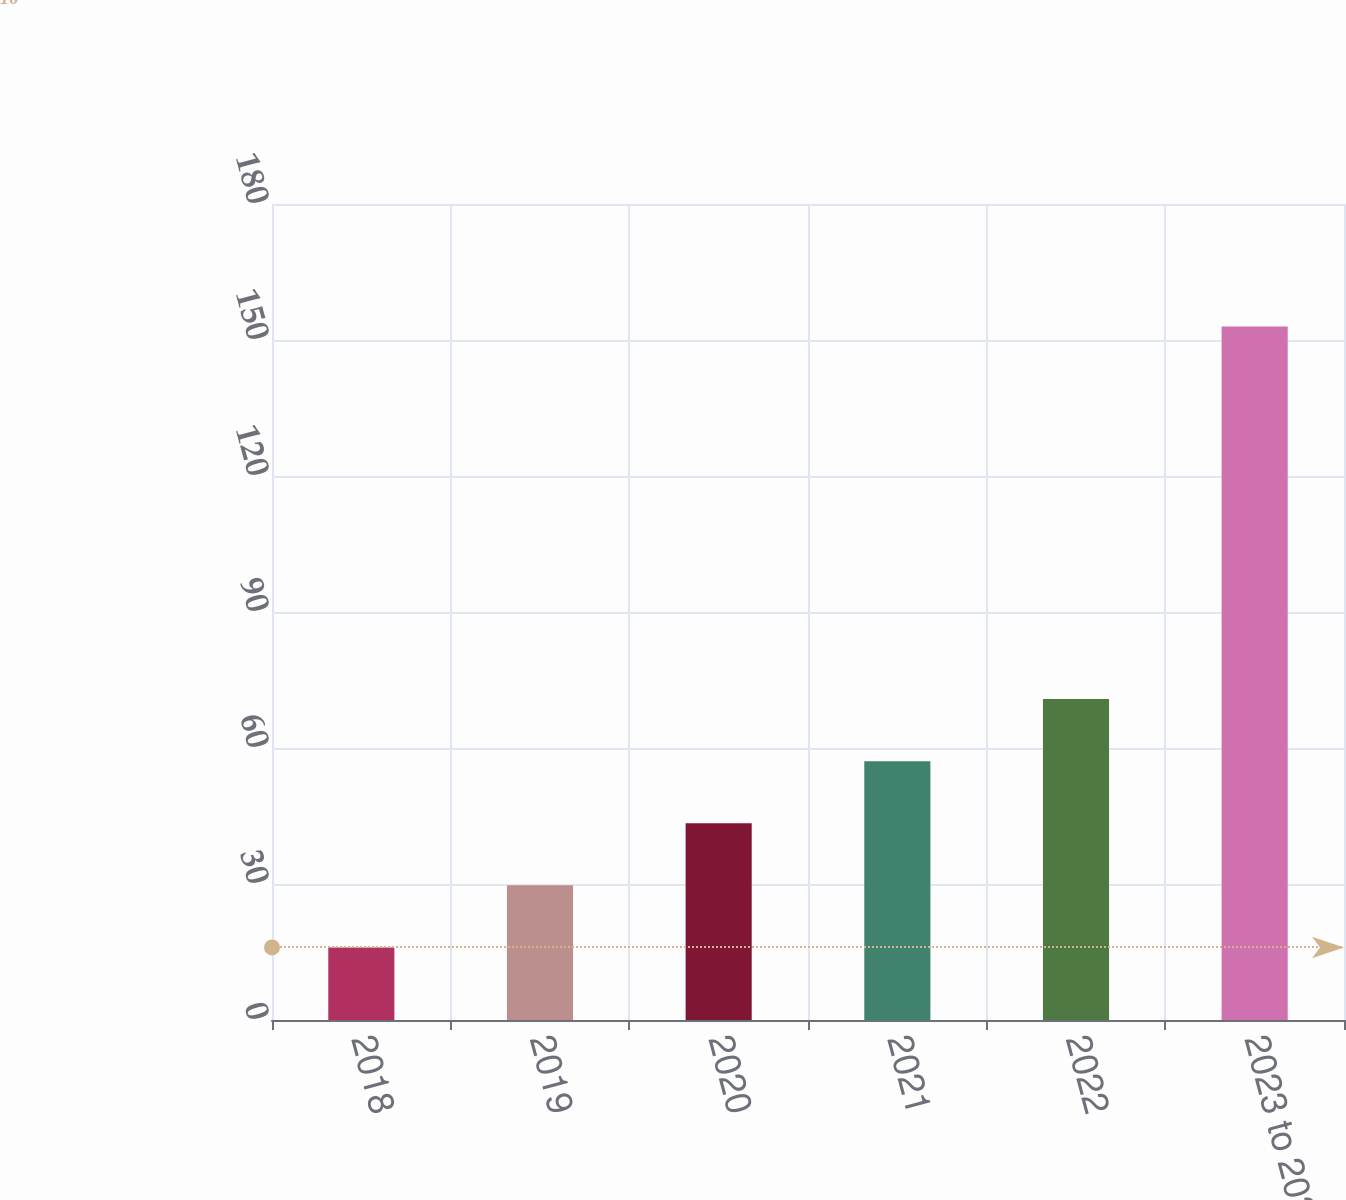Convert chart to OTSL. <chart><loc_0><loc_0><loc_500><loc_500><bar_chart><fcel>2018<fcel>2019<fcel>2020<fcel>2021<fcel>2022<fcel>2023 to 2027<nl><fcel>16<fcel>29.7<fcel>43.4<fcel>57.1<fcel>70.8<fcel>153<nl></chart> 